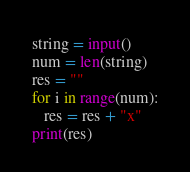<code> <loc_0><loc_0><loc_500><loc_500><_Python_>string = input()
num = len(string)
res = ""
for i in range(num):
   res = res + "x"
print(res)
</code> 